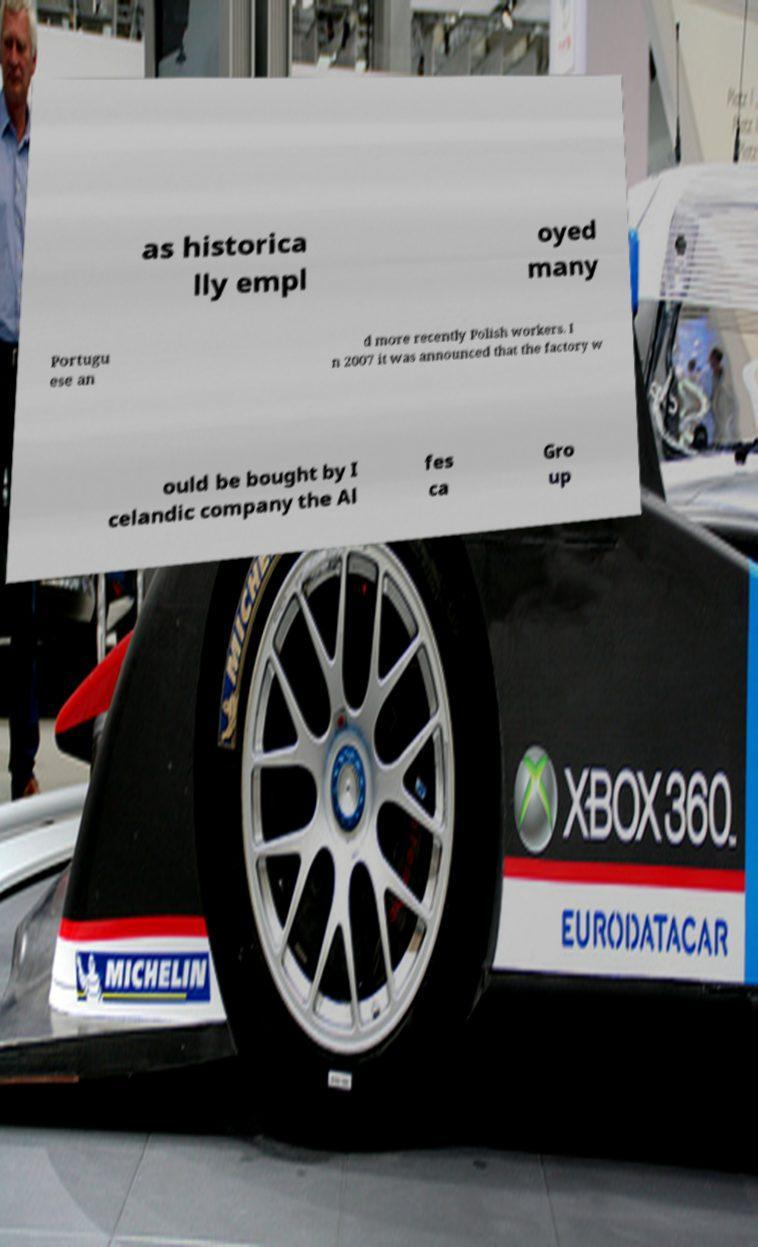Can you read and provide the text displayed in the image?This photo seems to have some interesting text. Can you extract and type it out for me? as historica lly empl oyed many Portugu ese an d more recently Polish workers. I n 2007 it was announced that the factory w ould be bought by I celandic company the Al fes ca Gro up 